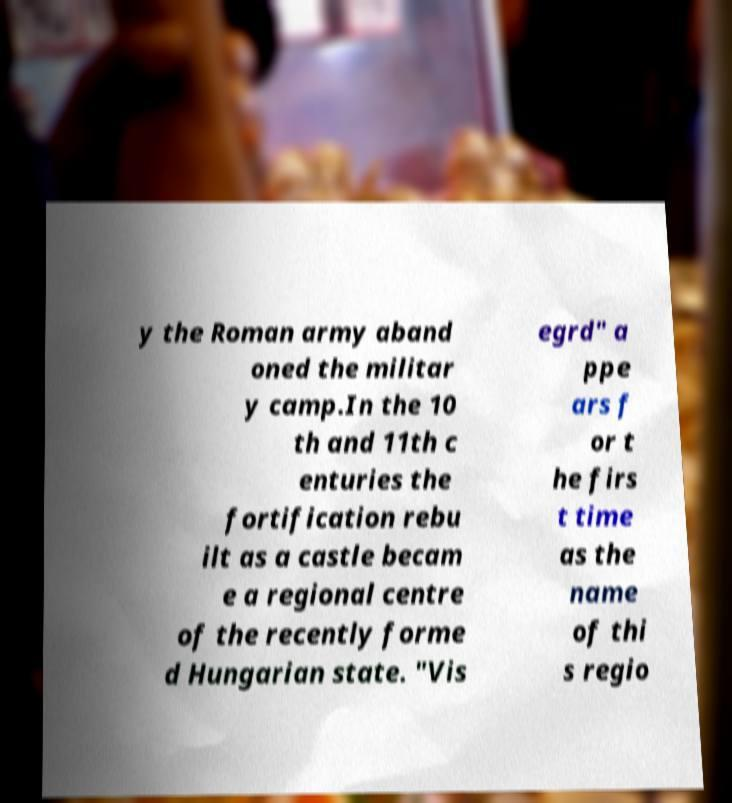I need the written content from this picture converted into text. Can you do that? y the Roman army aband oned the militar y camp.In the 10 th and 11th c enturies the fortification rebu ilt as a castle becam e a regional centre of the recently forme d Hungarian state. "Vis egrd" a ppe ars f or t he firs t time as the name of thi s regio 